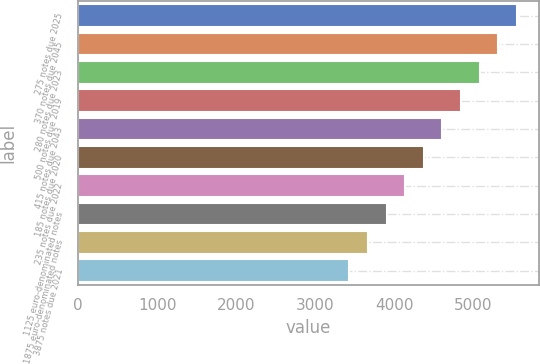<chart> <loc_0><loc_0><loc_500><loc_500><bar_chart><fcel>275 notes due 2025<fcel>370 notes due 2045<fcel>280 notes due 2023<fcel>500 notes due 2019<fcel>415 notes due 2043<fcel>185 notes due 2020<fcel>235 notes due 2022<fcel>1125 euro-denominated notes<fcel>1875 euro-denominated notes<fcel>3875 notes due 2021<nl><fcel>5546.9<fcel>5311.6<fcel>5076.3<fcel>4841<fcel>4605.7<fcel>4370.4<fcel>4135.1<fcel>3899.8<fcel>3664.5<fcel>3429.2<nl></chart> 